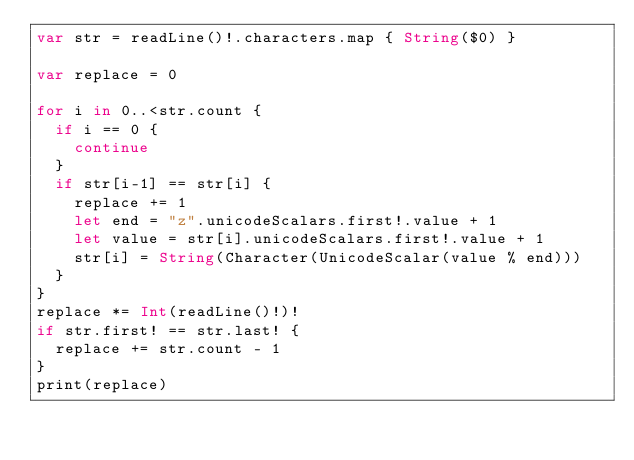<code> <loc_0><loc_0><loc_500><loc_500><_Swift_>var str = readLine()!.characters.map { String($0) }

var replace = 0

for i in 0..<str.count {
  if i == 0 {
    continue
  }
  if str[i-1] == str[i] {
    replace += 1
    let end = "z".unicodeScalars.first!.value + 1
    let value = str[i].unicodeScalars.first!.value + 1
    str[i] = String(Character(UnicodeScalar(value % end)))
  }
}
replace *= Int(readLine()!)!
if str.first! == str.last! {
  replace += str.count - 1
}
print(replace)</code> 